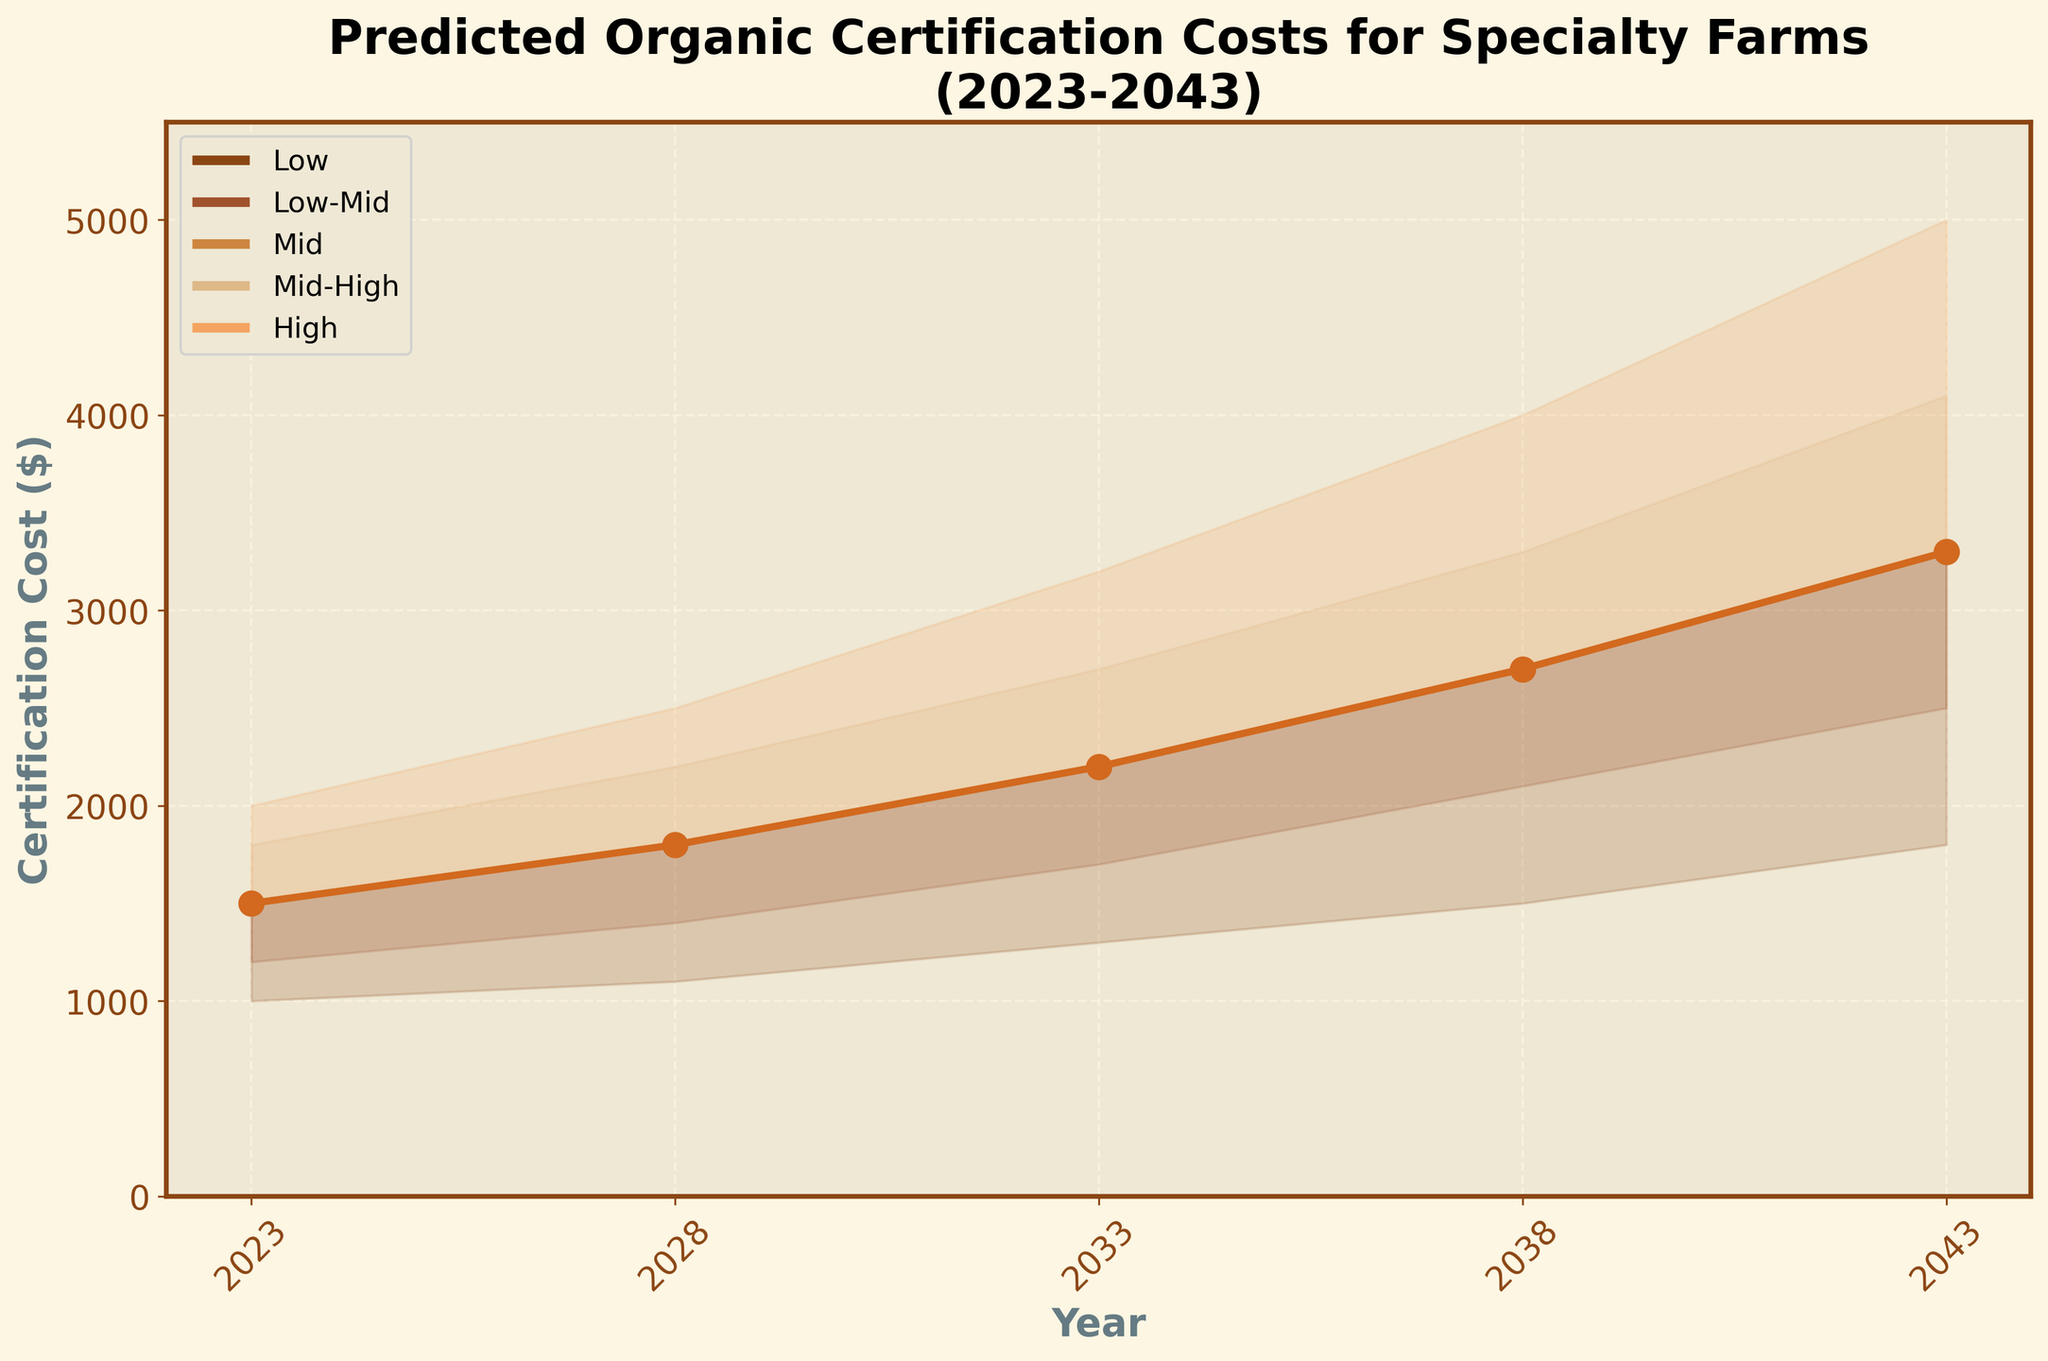What is the title of the chart? The title of the chart is prominently displayed at the top and reads, 'Predicted Organic Certification Costs for Specialty Farms (2023-2043)'.
Answer: Predicted Organic Certification Costs for Specialty Farms (2023-2043) How many years are shown on the x-axis? The x-axis shows the years, which are 2023, 2028, 2033, 2038, and 2043. By counting these distinct points, we determine there are five years shown.
Answer: 5 In what year is the mid-certification cost predicted to be $2700? Looking at the line representing the mid-certification costs, we find that the cost of $2700 coincides with the year 2038 in the figure.
Answer: 2038 Which year shows the highest predicted high-certification cost? The segment of the chart that depicts the highest costs reaches its peak at 2043, where the predicted high-certification cost appears to be the highest.
Answer: 2043 By how much does the mid-certification cost increase from 2023 to 2043? The mid-certification cost in 2023 is $1500, and in 2043 it is $3300. Therefore, the increase is calculated as $3300 - $1500.
Answer: $1800 What is the predicted cost range for 2028? In 2028, the low-certification cost is $1100, and the high-certification cost is $2500. Therefore, the range is $2500 - $1100.
Answer: $1400 What is the change in the low-certification cost from 2023 to 2038? The low-certification cost in 2023 is $1000, and in 2038 it is $1500. The change is calculated as $1500 - $1000.
Answer: $500 How do the predicted cost ranges (from low to high) change from 2028 to 2043? In 2028, the cost range is $2500 - $1100 = $1400. In 2043, it becomes $5000 - $1800 = $3200. Thus, the range increases by $3200 - $1400.
Answer: $1800 On which axis is the cost represented, and what is its range? The y-axis represents the certification cost, with a range from $0 to $5500. This is observable by looking at the labels and limits on the vertical axis.
Answer: Y-axis, $0 to $5500 